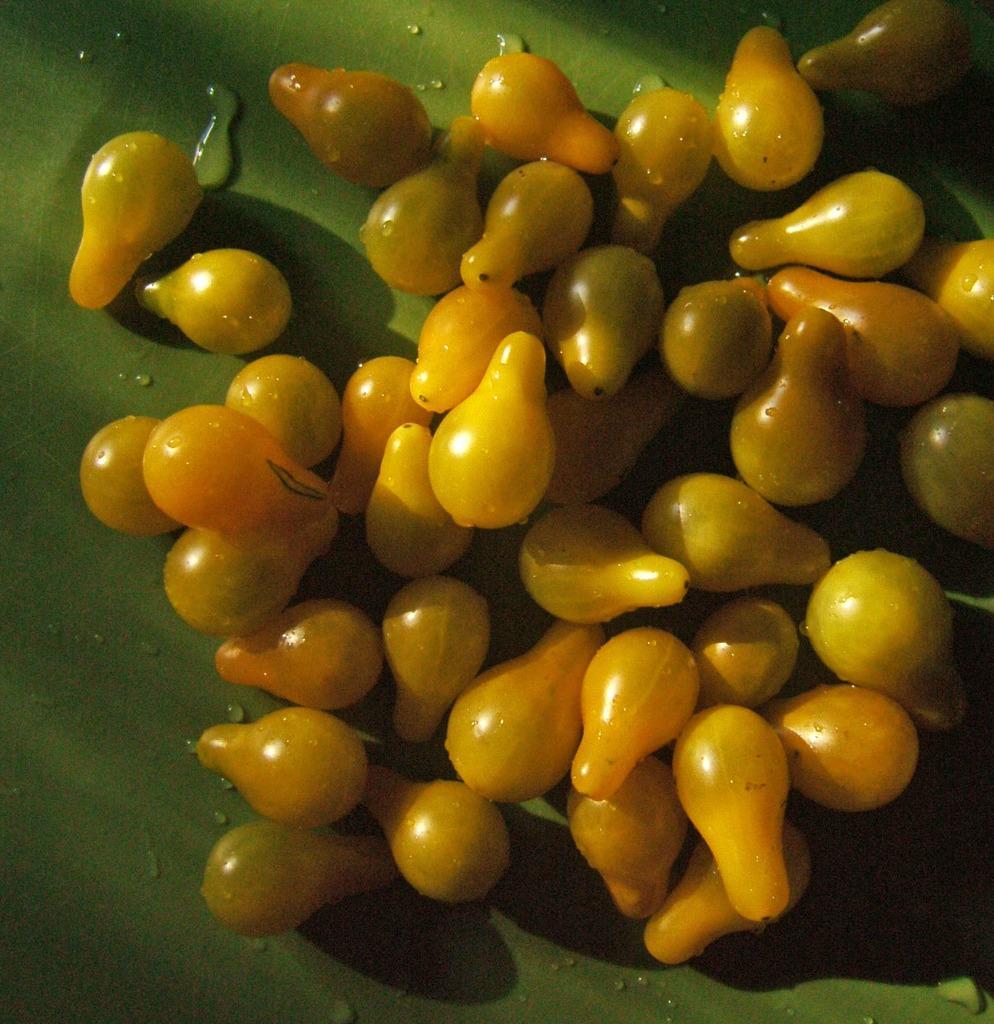In one or two sentences, can you explain what this image depicts? At the bottom of the image there is a table and there are a few fruits on the table. 